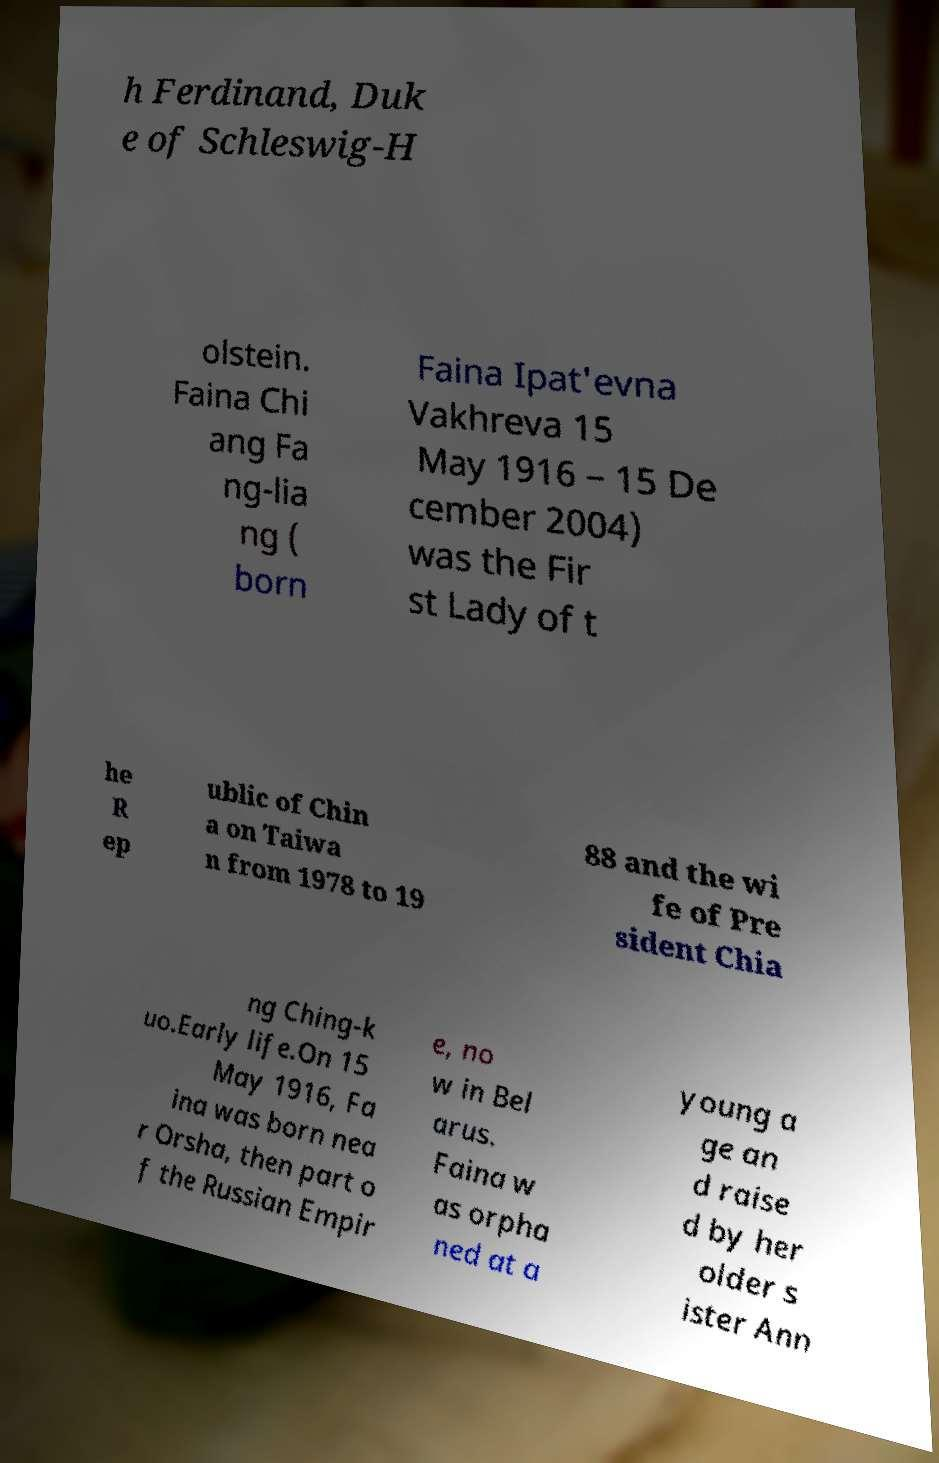Could you assist in decoding the text presented in this image and type it out clearly? h Ferdinand, Duk e of Schleswig-H olstein. Faina Chi ang Fa ng-lia ng ( born Faina Ipat'evna Vakhreva 15 May 1916 – 15 De cember 2004) was the Fir st Lady of t he R ep ublic of Chin a on Taiwa n from 1978 to 19 88 and the wi fe of Pre sident Chia ng Ching-k uo.Early life.On 15 May 1916, Fa ina was born nea r Orsha, then part o f the Russian Empir e, no w in Bel arus. Faina w as orpha ned at a young a ge an d raise d by her older s ister Ann 